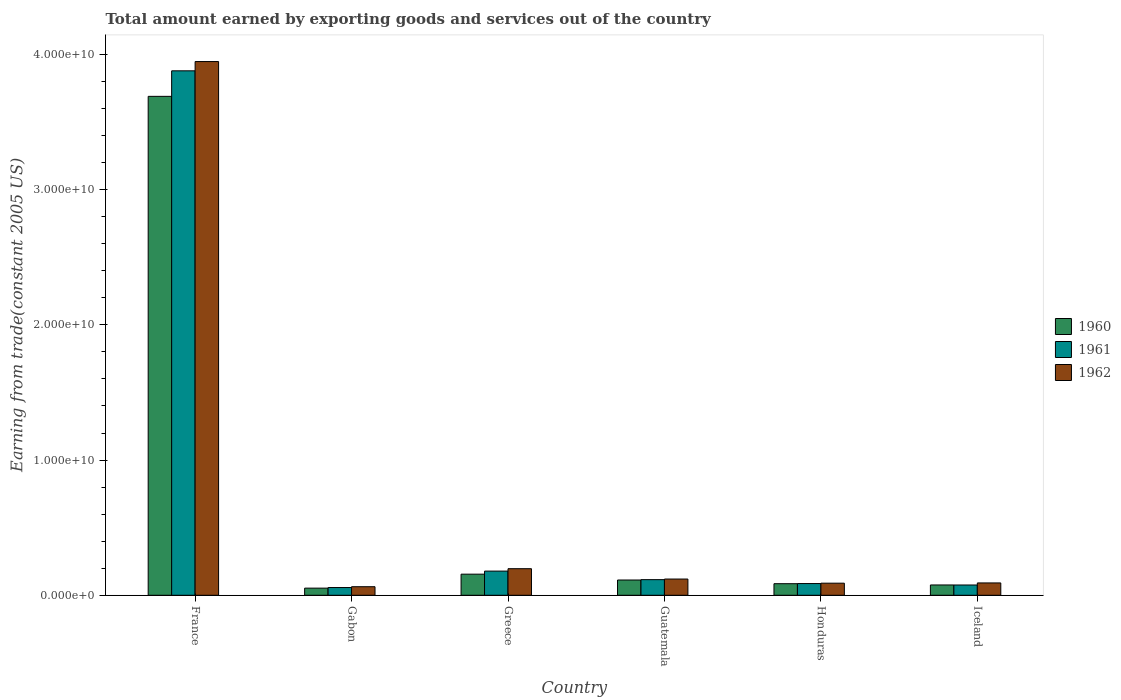How many different coloured bars are there?
Your answer should be very brief. 3. Are the number of bars per tick equal to the number of legend labels?
Ensure brevity in your answer.  Yes. How many bars are there on the 5th tick from the left?
Your answer should be very brief. 3. How many bars are there on the 5th tick from the right?
Offer a very short reply. 3. What is the label of the 3rd group of bars from the left?
Your response must be concise. Greece. In how many cases, is the number of bars for a given country not equal to the number of legend labels?
Make the answer very short. 0. What is the total amount earned by exporting goods and services in 1961 in Greece?
Keep it short and to the point. 1.79e+09. Across all countries, what is the maximum total amount earned by exporting goods and services in 1962?
Make the answer very short. 3.95e+1. Across all countries, what is the minimum total amount earned by exporting goods and services in 1961?
Offer a terse response. 5.72e+08. In which country was the total amount earned by exporting goods and services in 1960 minimum?
Your response must be concise. Gabon. What is the total total amount earned by exporting goods and services in 1960 in the graph?
Your response must be concise. 4.17e+1. What is the difference between the total amount earned by exporting goods and services in 1960 in Gabon and that in Greece?
Provide a succinct answer. -1.03e+09. What is the difference between the total amount earned by exporting goods and services in 1962 in Gabon and the total amount earned by exporting goods and services in 1960 in France?
Your answer should be compact. -3.63e+1. What is the average total amount earned by exporting goods and services in 1962 per country?
Ensure brevity in your answer.  7.51e+09. What is the difference between the total amount earned by exporting goods and services of/in 1961 and total amount earned by exporting goods and services of/in 1962 in Greece?
Offer a terse response. -1.78e+08. What is the ratio of the total amount earned by exporting goods and services in 1960 in Gabon to that in Honduras?
Ensure brevity in your answer.  0.62. Is the total amount earned by exporting goods and services in 1960 in France less than that in Honduras?
Make the answer very short. No. Is the difference between the total amount earned by exporting goods and services in 1961 in France and Gabon greater than the difference between the total amount earned by exporting goods and services in 1962 in France and Gabon?
Your answer should be compact. No. What is the difference between the highest and the second highest total amount earned by exporting goods and services in 1962?
Your answer should be very brief. 3.75e+1. What is the difference between the highest and the lowest total amount earned by exporting goods and services in 1961?
Offer a terse response. 3.82e+1. In how many countries, is the total amount earned by exporting goods and services in 1961 greater than the average total amount earned by exporting goods and services in 1961 taken over all countries?
Offer a terse response. 1. Is the sum of the total amount earned by exporting goods and services in 1961 in France and Greece greater than the maximum total amount earned by exporting goods and services in 1960 across all countries?
Give a very brief answer. Yes. What does the 3rd bar from the right in Honduras represents?
Keep it short and to the point. 1960. How many bars are there?
Make the answer very short. 18. Are all the bars in the graph horizontal?
Make the answer very short. No. How many countries are there in the graph?
Make the answer very short. 6. Are the values on the major ticks of Y-axis written in scientific E-notation?
Offer a very short reply. Yes. Does the graph contain any zero values?
Give a very brief answer. No. Does the graph contain grids?
Offer a very short reply. No. How are the legend labels stacked?
Give a very brief answer. Vertical. What is the title of the graph?
Your answer should be very brief. Total amount earned by exporting goods and services out of the country. Does "2007" appear as one of the legend labels in the graph?
Make the answer very short. No. What is the label or title of the Y-axis?
Provide a succinct answer. Earning from trade(constant 2005 US). What is the Earning from trade(constant 2005 US) of 1960 in France?
Keep it short and to the point. 3.69e+1. What is the Earning from trade(constant 2005 US) in 1961 in France?
Give a very brief answer. 3.88e+1. What is the Earning from trade(constant 2005 US) in 1962 in France?
Ensure brevity in your answer.  3.95e+1. What is the Earning from trade(constant 2005 US) in 1960 in Gabon?
Provide a succinct answer. 5.28e+08. What is the Earning from trade(constant 2005 US) in 1961 in Gabon?
Offer a terse response. 5.72e+08. What is the Earning from trade(constant 2005 US) of 1962 in Gabon?
Offer a terse response. 6.33e+08. What is the Earning from trade(constant 2005 US) of 1960 in Greece?
Offer a terse response. 1.56e+09. What is the Earning from trade(constant 2005 US) of 1961 in Greece?
Your answer should be compact. 1.79e+09. What is the Earning from trade(constant 2005 US) of 1962 in Greece?
Offer a terse response. 1.97e+09. What is the Earning from trade(constant 2005 US) in 1960 in Guatemala?
Offer a very short reply. 1.13e+09. What is the Earning from trade(constant 2005 US) of 1961 in Guatemala?
Your answer should be very brief. 1.16e+09. What is the Earning from trade(constant 2005 US) in 1962 in Guatemala?
Offer a terse response. 1.20e+09. What is the Earning from trade(constant 2005 US) in 1960 in Honduras?
Provide a succinct answer. 8.56e+08. What is the Earning from trade(constant 2005 US) in 1961 in Honduras?
Your answer should be very brief. 8.66e+08. What is the Earning from trade(constant 2005 US) in 1962 in Honduras?
Ensure brevity in your answer.  8.95e+08. What is the Earning from trade(constant 2005 US) of 1960 in Iceland?
Ensure brevity in your answer.  7.62e+08. What is the Earning from trade(constant 2005 US) of 1961 in Iceland?
Your answer should be compact. 7.60e+08. What is the Earning from trade(constant 2005 US) of 1962 in Iceland?
Offer a very short reply. 9.12e+08. Across all countries, what is the maximum Earning from trade(constant 2005 US) of 1960?
Your answer should be compact. 3.69e+1. Across all countries, what is the maximum Earning from trade(constant 2005 US) of 1961?
Offer a terse response. 3.88e+1. Across all countries, what is the maximum Earning from trade(constant 2005 US) in 1962?
Offer a very short reply. 3.95e+1. Across all countries, what is the minimum Earning from trade(constant 2005 US) in 1960?
Your answer should be very brief. 5.28e+08. Across all countries, what is the minimum Earning from trade(constant 2005 US) in 1961?
Ensure brevity in your answer.  5.72e+08. Across all countries, what is the minimum Earning from trade(constant 2005 US) in 1962?
Provide a succinct answer. 6.33e+08. What is the total Earning from trade(constant 2005 US) in 1960 in the graph?
Give a very brief answer. 4.17e+1. What is the total Earning from trade(constant 2005 US) of 1961 in the graph?
Your response must be concise. 4.39e+1. What is the total Earning from trade(constant 2005 US) in 1962 in the graph?
Provide a succinct answer. 4.51e+1. What is the difference between the Earning from trade(constant 2005 US) of 1960 in France and that in Gabon?
Your answer should be compact. 3.64e+1. What is the difference between the Earning from trade(constant 2005 US) in 1961 in France and that in Gabon?
Your response must be concise. 3.82e+1. What is the difference between the Earning from trade(constant 2005 US) in 1962 in France and that in Gabon?
Make the answer very short. 3.88e+1. What is the difference between the Earning from trade(constant 2005 US) of 1960 in France and that in Greece?
Your response must be concise. 3.53e+1. What is the difference between the Earning from trade(constant 2005 US) in 1961 in France and that in Greece?
Give a very brief answer. 3.70e+1. What is the difference between the Earning from trade(constant 2005 US) in 1962 in France and that in Greece?
Give a very brief answer. 3.75e+1. What is the difference between the Earning from trade(constant 2005 US) of 1960 in France and that in Guatemala?
Offer a terse response. 3.58e+1. What is the difference between the Earning from trade(constant 2005 US) of 1961 in France and that in Guatemala?
Your answer should be compact. 3.76e+1. What is the difference between the Earning from trade(constant 2005 US) in 1962 in France and that in Guatemala?
Provide a short and direct response. 3.83e+1. What is the difference between the Earning from trade(constant 2005 US) in 1960 in France and that in Honduras?
Your answer should be compact. 3.60e+1. What is the difference between the Earning from trade(constant 2005 US) in 1961 in France and that in Honduras?
Your answer should be very brief. 3.79e+1. What is the difference between the Earning from trade(constant 2005 US) of 1962 in France and that in Honduras?
Keep it short and to the point. 3.86e+1. What is the difference between the Earning from trade(constant 2005 US) of 1960 in France and that in Iceland?
Give a very brief answer. 3.61e+1. What is the difference between the Earning from trade(constant 2005 US) of 1961 in France and that in Iceland?
Keep it short and to the point. 3.80e+1. What is the difference between the Earning from trade(constant 2005 US) of 1962 in France and that in Iceland?
Ensure brevity in your answer.  3.86e+1. What is the difference between the Earning from trade(constant 2005 US) in 1960 in Gabon and that in Greece?
Offer a very short reply. -1.03e+09. What is the difference between the Earning from trade(constant 2005 US) of 1961 in Gabon and that in Greece?
Ensure brevity in your answer.  -1.22e+09. What is the difference between the Earning from trade(constant 2005 US) of 1962 in Gabon and that in Greece?
Provide a short and direct response. -1.33e+09. What is the difference between the Earning from trade(constant 2005 US) of 1960 in Gabon and that in Guatemala?
Make the answer very short. -6.01e+08. What is the difference between the Earning from trade(constant 2005 US) in 1961 in Gabon and that in Guatemala?
Give a very brief answer. -5.84e+08. What is the difference between the Earning from trade(constant 2005 US) in 1962 in Gabon and that in Guatemala?
Provide a succinct answer. -5.67e+08. What is the difference between the Earning from trade(constant 2005 US) of 1960 in Gabon and that in Honduras?
Ensure brevity in your answer.  -3.28e+08. What is the difference between the Earning from trade(constant 2005 US) of 1961 in Gabon and that in Honduras?
Provide a succinct answer. -2.94e+08. What is the difference between the Earning from trade(constant 2005 US) of 1962 in Gabon and that in Honduras?
Your answer should be compact. -2.61e+08. What is the difference between the Earning from trade(constant 2005 US) in 1960 in Gabon and that in Iceland?
Offer a very short reply. -2.34e+08. What is the difference between the Earning from trade(constant 2005 US) in 1961 in Gabon and that in Iceland?
Offer a terse response. -1.88e+08. What is the difference between the Earning from trade(constant 2005 US) of 1962 in Gabon and that in Iceland?
Offer a very short reply. -2.79e+08. What is the difference between the Earning from trade(constant 2005 US) in 1960 in Greece and that in Guatemala?
Your response must be concise. 4.31e+08. What is the difference between the Earning from trade(constant 2005 US) in 1961 in Greece and that in Guatemala?
Provide a succinct answer. 6.32e+08. What is the difference between the Earning from trade(constant 2005 US) in 1962 in Greece and that in Guatemala?
Ensure brevity in your answer.  7.65e+08. What is the difference between the Earning from trade(constant 2005 US) in 1960 in Greece and that in Honduras?
Your answer should be compact. 7.05e+08. What is the difference between the Earning from trade(constant 2005 US) of 1961 in Greece and that in Honduras?
Ensure brevity in your answer.  9.21e+08. What is the difference between the Earning from trade(constant 2005 US) of 1962 in Greece and that in Honduras?
Keep it short and to the point. 1.07e+09. What is the difference between the Earning from trade(constant 2005 US) in 1960 in Greece and that in Iceland?
Keep it short and to the point. 7.98e+08. What is the difference between the Earning from trade(constant 2005 US) in 1961 in Greece and that in Iceland?
Provide a succinct answer. 1.03e+09. What is the difference between the Earning from trade(constant 2005 US) in 1962 in Greece and that in Iceland?
Make the answer very short. 1.05e+09. What is the difference between the Earning from trade(constant 2005 US) in 1960 in Guatemala and that in Honduras?
Ensure brevity in your answer.  2.73e+08. What is the difference between the Earning from trade(constant 2005 US) in 1961 in Guatemala and that in Honduras?
Your answer should be compact. 2.89e+08. What is the difference between the Earning from trade(constant 2005 US) of 1962 in Guatemala and that in Honduras?
Give a very brief answer. 3.06e+08. What is the difference between the Earning from trade(constant 2005 US) of 1960 in Guatemala and that in Iceland?
Make the answer very short. 3.67e+08. What is the difference between the Earning from trade(constant 2005 US) in 1961 in Guatemala and that in Iceland?
Provide a succinct answer. 3.96e+08. What is the difference between the Earning from trade(constant 2005 US) in 1962 in Guatemala and that in Iceland?
Your answer should be very brief. 2.88e+08. What is the difference between the Earning from trade(constant 2005 US) in 1960 in Honduras and that in Iceland?
Give a very brief answer. 9.37e+07. What is the difference between the Earning from trade(constant 2005 US) of 1961 in Honduras and that in Iceland?
Your response must be concise. 1.06e+08. What is the difference between the Earning from trade(constant 2005 US) of 1962 in Honduras and that in Iceland?
Give a very brief answer. -1.79e+07. What is the difference between the Earning from trade(constant 2005 US) of 1960 in France and the Earning from trade(constant 2005 US) of 1961 in Gabon?
Your answer should be very brief. 3.63e+1. What is the difference between the Earning from trade(constant 2005 US) in 1960 in France and the Earning from trade(constant 2005 US) in 1962 in Gabon?
Provide a short and direct response. 3.63e+1. What is the difference between the Earning from trade(constant 2005 US) in 1961 in France and the Earning from trade(constant 2005 US) in 1962 in Gabon?
Make the answer very short. 3.82e+1. What is the difference between the Earning from trade(constant 2005 US) of 1960 in France and the Earning from trade(constant 2005 US) of 1961 in Greece?
Provide a short and direct response. 3.51e+1. What is the difference between the Earning from trade(constant 2005 US) of 1960 in France and the Earning from trade(constant 2005 US) of 1962 in Greece?
Keep it short and to the point. 3.49e+1. What is the difference between the Earning from trade(constant 2005 US) of 1961 in France and the Earning from trade(constant 2005 US) of 1962 in Greece?
Provide a short and direct response. 3.68e+1. What is the difference between the Earning from trade(constant 2005 US) in 1960 in France and the Earning from trade(constant 2005 US) in 1961 in Guatemala?
Your answer should be very brief. 3.57e+1. What is the difference between the Earning from trade(constant 2005 US) of 1960 in France and the Earning from trade(constant 2005 US) of 1962 in Guatemala?
Give a very brief answer. 3.57e+1. What is the difference between the Earning from trade(constant 2005 US) of 1961 in France and the Earning from trade(constant 2005 US) of 1962 in Guatemala?
Keep it short and to the point. 3.76e+1. What is the difference between the Earning from trade(constant 2005 US) in 1960 in France and the Earning from trade(constant 2005 US) in 1961 in Honduras?
Your response must be concise. 3.60e+1. What is the difference between the Earning from trade(constant 2005 US) in 1960 in France and the Earning from trade(constant 2005 US) in 1962 in Honduras?
Your answer should be compact. 3.60e+1. What is the difference between the Earning from trade(constant 2005 US) in 1961 in France and the Earning from trade(constant 2005 US) in 1962 in Honduras?
Your answer should be compact. 3.79e+1. What is the difference between the Earning from trade(constant 2005 US) in 1960 in France and the Earning from trade(constant 2005 US) in 1961 in Iceland?
Keep it short and to the point. 3.61e+1. What is the difference between the Earning from trade(constant 2005 US) in 1960 in France and the Earning from trade(constant 2005 US) in 1962 in Iceland?
Make the answer very short. 3.60e+1. What is the difference between the Earning from trade(constant 2005 US) in 1961 in France and the Earning from trade(constant 2005 US) in 1962 in Iceland?
Give a very brief answer. 3.79e+1. What is the difference between the Earning from trade(constant 2005 US) in 1960 in Gabon and the Earning from trade(constant 2005 US) in 1961 in Greece?
Your answer should be very brief. -1.26e+09. What is the difference between the Earning from trade(constant 2005 US) of 1960 in Gabon and the Earning from trade(constant 2005 US) of 1962 in Greece?
Give a very brief answer. -1.44e+09. What is the difference between the Earning from trade(constant 2005 US) of 1961 in Gabon and the Earning from trade(constant 2005 US) of 1962 in Greece?
Your response must be concise. -1.39e+09. What is the difference between the Earning from trade(constant 2005 US) in 1960 in Gabon and the Earning from trade(constant 2005 US) in 1961 in Guatemala?
Provide a succinct answer. -6.27e+08. What is the difference between the Earning from trade(constant 2005 US) of 1960 in Gabon and the Earning from trade(constant 2005 US) of 1962 in Guatemala?
Ensure brevity in your answer.  -6.72e+08. What is the difference between the Earning from trade(constant 2005 US) of 1961 in Gabon and the Earning from trade(constant 2005 US) of 1962 in Guatemala?
Your answer should be compact. -6.28e+08. What is the difference between the Earning from trade(constant 2005 US) of 1960 in Gabon and the Earning from trade(constant 2005 US) of 1961 in Honduras?
Offer a terse response. -3.38e+08. What is the difference between the Earning from trade(constant 2005 US) in 1960 in Gabon and the Earning from trade(constant 2005 US) in 1962 in Honduras?
Your response must be concise. -3.66e+08. What is the difference between the Earning from trade(constant 2005 US) of 1961 in Gabon and the Earning from trade(constant 2005 US) of 1962 in Honduras?
Provide a short and direct response. -3.23e+08. What is the difference between the Earning from trade(constant 2005 US) in 1960 in Gabon and the Earning from trade(constant 2005 US) in 1961 in Iceland?
Provide a short and direct response. -2.32e+08. What is the difference between the Earning from trade(constant 2005 US) of 1960 in Gabon and the Earning from trade(constant 2005 US) of 1962 in Iceland?
Keep it short and to the point. -3.84e+08. What is the difference between the Earning from trade(constant 2005 US) in 1961 in Gabon and the Earning from trade(constant 2005 US) in 1962 in Iceland?
Provide a succinct answer. -3.40e+08. What is the difference between the Earning from trade(constant 2005 US) of 1960 in Greece and the Earning from trade(constant 2005 US) of 1961 in Guatemala?
Provide a succinct answer. 4.05e+08. What is the difference between the Earning from trade(constant 2005 US) in 1960 in Greece and the Earning from trade(constant 2005 US) in 1962 in Guatemala?
Provide a short and direct response. 3.61e+08. What is the difference between the Earning from trade(constant 2005 US) of 1961 in Greece and the Earning from trade(constant 2005 US) of 1962 in Guatemala?
Give a very brief answer. 5.87e+08. What is the difference between the Earning from trade(constant 2005 US) of 1960 in Greece and the Earning from trade(constant 2005 US) of 1961 in Honduras?
Your answer should be very brief. 6.94e+08. What is the difference between the Earning from trade(constant 2005 US) in 1960 in Greece and the Earning from trade(constant 2005 US) in 1962 in Honduras?
Offer a terse response. 6.66e+08. What is the difference between the Earning from trade(constant 2005 US) in 1961 in Greece and the Earning from trade(constant 2005 US) in 1962 in Honduras?
Make the answer very short. 8.93e+08. What is the difference between the Earning from trade(constant 2005 US) in 1960 in Greece and the Earning from trade(constant 2005 US) in 1961 in Iceland?
Your answer should be compact. 8.01e+08. What is the difference between the Earning from trade(constant 2005 US) in 1960 in Greece and the Earning from trade(constant 2005 US) in 1962 in Iceland?
Your response must be concise. 6.48e+08. What is the difference between the Earning from trade(constant 2005 US) of 1961 in Greece and the Earning from trade(constant 2005 US) of 1962 in Iceland?
Provide a short and direct response. 8.75e+08. What is the difference between the Earning from trade(constant 2005 US) in 1960 in Guatemala and the Earning from trade(constant 2005 US) in 1961 in Honduras?
Make the answer very short. 2.63e+08. What is the difference between the Earning from trade(constant 2005 US) in 1960 in Guatemala and the Earning from trade(constant 2005 US) in 1962 in Honduras?
Make the answer very short. 2.35e+08. What is the difference between the Earning from trade(constant 2005 US) in 1961 in Guatemala and the Earning from trade(constant 2005 US) in 1962 in Honduras?
Your answer should be compact. 2.61e+08. What is the difference between the Earning from trade(constant 2005 US) of 1960 in Guatemala and the Earning from trade(constant 2005 US) of 1961 in Iceland?
Provide a succinct answer. 3.69e+08. What is the difference between the Earning from trade(constant 2005 US) in 1960 in Guatemala and the Earning from trade(constant 2005 US) in 1962 in Iceland?
Make the answer very short. 2.17e+08. What is the difference between the Earning from trade(constant 2005 US) in 1961 in Guatemala and the Earning from trade(constant 2005 US) in 1962 in Iceland?
Offer a very short reply. 2.43e+08. What is the difference between the Earning from trade(constant 2005 US) in 1960 in Honduras and the Earning from trade(constant 2005 US) in 1961 in Iceland?
Offer a very short reply. 9.63e+07. What is the difference between the Earning from trade(constant 2005 US) in 1960 in Honduras and the Earning from trade(constant 2005 US) in 1962 in Iceland?
Offer a terse response. -5.63e+07. What is the difference between the Earning from trade(constant 2005 US) of 1961 in Honduras and the Earning from trade(constant 2005 US) of 1962 in Iceland?
Offer a very short reply. -4.61e+07. What is the average Earning from trade(constant 2005 US) in 1960 per country?
Keep it short and to the point. 6.96e+09. What is the average Earning from trade(constant 2005 US) of 1961 per country?
Ensure brevity in your answer.  7.32e+09. What is the average Earning from trade(constant 2005 US) of 1962 per country?
Your response must be concise. 7.51e+09. What is the difference between the Earning from trade(constant 2005 US) in 1960 and Earning from trade(constant 2005 US) in 1961 in France?
Keep it short and to the point. -1.89e+09. What is the difference between the Earning from trade(constant 2005 US) of 1960 and Earning from trade(constant 2005 US) of 1962 in France?
Give a very brief answer. -2.57e+09. What is the difference between the Earning from trade(constant 2005 US) of 1961 and Earning from trade(constant 2005 US) of 1962 in France?
Your answer should be very brief. -6.85e+08. What is the difference between the Earning from trade(constant 2005 US) of 1960 and Earning from trade(constant 2005 US) of 1961 in Gabon?
Your answer should be very brief. -4.37e+07. What is the difference between the Earning from trade(constant 2005 US) of 1960 and Earning from trade(constant 2005 US) of 1962 in Gabon?
Offer a terse response. -1.05e+08. What is the difference between the Earning from trade(constant 2005 US) of 1961 and Earning from trade(constant 2005 US) of 1962 in Gabon?
Give a very brief answer. -6.11e+07. What is the difference between the Earning from trade(constant 2005 US) in 1960 and Earning from trade(constant 2005 US) in 1961 in Greece?
Your answer should be very brief. -2.27e+08. What is the difference between the Earning from trade(constant 2005 US) of 1960 and Earning from trade(constant 2005 US) of 1962 in Greece?
Make the answer very short. -4.05e+08. What is the difference between the Earning from trade(constant 2005 US) of 1961 and Earning from trade(constant 2005 US) of 1962 in Greece?
Provide a short and direct response. -1.78e+08. What is the difference between the Earning from trade(constant 2005 US) in 1960 and Earning from trade(constant 2005 US) in 1961 in Guatemala?
Ensure brevity in your answer.  -2.66e+07. What is the difference between the Earning from trade(constant 2005 US) in 1960 and Earning from trade(constant 2005 US) in 1962 in Guatemala?
Keep it short and to the point. -7.09e+07. What is the difference between the Earning from trade(constant 2005 US) of 1961 and Earning from trade(constant 2005 US) of 1962 in Guatemala?
Provide a succinct answer. -4.43e+07. What is the difference between the Earning from trade(constant 2005 US) of 1960 and Earning from trade(constant 2005 US) of 1961 in Honduras?
Your response must be concise. -1.02e+07. What is the difference between the Earning from trade(constant 2005 US) in 1960 and Earning from trade(constant 2005 US) in 1962 in Honduras?
Offer a very short reply. -3.84e+07. What is the difference between the Earning from trade(constant 2005 US) in 1961 and Earning from trade(constant 2005 US) in 1962 in Honduras?
Make the answer very short. -2.82e+07. What is the difference between the Earning from trade(constant 2005 US) of 1960 and Earning from trade(constant 2005 US) of 1961 in Iceland?
Your answer should be very brief. 2.61e+06. What is the difference between the Earning from trade(constant 2005 US) in 1960 and Earning from trade(constant 2005 US) in 1962 in Iceland?
Ensure brevity in your answer.  -1.50e+08. What is the difference between the Earning from trade(constant 2005 US) of 1961 and Earning from trade(constant 2005 US) of 1962 in Iceland?
Provide a short and direct response. -1.53e+08. What is the ratio of the Earning from trade(constant 2005 US) in 1960 in France to that in Gabon?
Give a very brief answer. 69.83. What is the ratio of the Earning from trade(constant 2005 US) in 1961 in France to that in Gabon?
Offer a very short reply. 67.8. What is the ratio of the Earning from trade(constant 2005 US) in 1962 in France to that in Gabon?
Ensure brevity in your answer.  62.34. What is the ratio of the Earning from trade(constant 2005 US) of 1960 in France to that in Greece?
Your answer should be compact. 23.64. What is the ratio of the Earning from trade(constant 2005 US) in 1961 in France to that in Greece?
Provide a succinct answer. 21.7. What is the ratio of the Earning from trade(constant 2005 US) in 1962 in France to that in Greece?
Your answer should be very brief. 20.08. What is the ratio of the Earning from trade(constant 2005 US) in 1960 in France to that in Guatemala?
Offer a very short reply. 32.67. What is the ratio of the Earning from trade(constant 2005 US) in 1961 in France to that in Guatemala?
Provide a short and direct response. 33.56. What is the ratio of the Earning from trade(constant 2005 US) of 1962 in France to that in Guatemala?
Give a very brief answer. 32.89. What is the ratio of the Earning from trade(constant 2005 US) in 1960 in France to that in Honduras?
Provide a short and direct response. 43.1. What is the ratio of the Earning from trade(constant 2005 US) of 1961 in France to that in Honduras?
Ensure brevity in your answer.  44.77. What is the ratio of the Earning from trade(constant 2005 US) in 1962 in France to that in Honduras?
Your answer should be very brief. 44.12. What is the ratio of the Earning from trade(constant 2005 US) of 1960 in France to that in Iceland?
Give a very brief answer. 48.39. What is the ratio of the Earning from trade(constant 2005 US) in 1961 in France to that in Iceland?
Your response must be concise. 51.04. What is the ratio of the Earning from trade(constant 2005 US) in 1962 in France to that in Iceland?
Provide a short and direct response. 43.26. What is the ratio of the Earning from trade(constant 2005 US) in 1960 in Gabon to that in Greece?
Your answer should be very brief. 0.34. What is the ratio of the Earning from trade(constant 2005 US) of 1961 in Gabon to that in Greece?
Offer a very short reply. 0.32. What is the ratio of the Earning from trade(constant 2005 US) of 1962 in Gabon to that in Greece?
Ensure brevity in your answer.  0.32. What is the ratio of the Earning from trade(constant 2005 US) in 1960 in Gabon to that in Guatemala?
Offer a very short reply. 0.47. What is the ratio of the Earning from trade(constant 2005 US) of 1961 in Gabon to that in Guatemala?
Offer a very short reply. 0.49. What is the ratio of the Earning from trade(constant 2005 US) of 1962 in Gabon to that in Guatemala?
Offer a very short reply. 0.53. What is the ratio of the Earning from trade(constant 2005 US) of 1960 in Gabon to that in Honduras?
Offer a very short reply. 0.62. What is the ratio of the Earning from trade(constant 2005 US) in 1961 in Gabon to that in Honduras?
Your response must be concise. 0.66. What is the ratio of the Earning from trade(constant 2005 US) of 1962 in Gabon to that in Honduras?
Offer a terse response. 0.71. What is the ratio of the Earning from trade(constant 2005 US) of 1960 in Gabon to that in Iceland?
Your response must be concise. 0.69. What is the ratio of the Earning from trade(constant 2005 US) in 1961 in Gabon to that in Iceland?
Offer a very short reply. 0.75. What is the ratio of the Earning from trade(constant 2005 US) in 1962 in Gabon to that in Iceland?
Your response must be concise. 0.69. What is the ratio of the Earning from trade(constant 2005 US) in 1960 in Greece to that in Guatemala?
Your response must be concise. 1.38. What is the ratio of the Earning from trade(constant 2005 US) of 1961 in Greece to that in Guatemala?
Give a very brief answer. 1.55. What is the ratio of the Earning from trade(constant 2005 US) in 1962 in Greece to that in Guatemala?
Keep it short and to the point. 1.64. What is the ratio of the Earning from trade(constant 2005 US) of 1960 in Greece to that in Honduras?
Your response must be concise. 1.82. What is the ratio of the Earning from trade(constant 2005 US) of 1961 in Greece to that in Honduras?
Your response must be concise. 2.06. What is the ratio of the Earning from trade(constant 2005 US) in 1962 in Greece to that in Honduras?
Offer a very short reply. 2.2. What is the ratio of the Earning from trade(constant 2005 US) of 1960 in Greece to that in Iceland?
Make the answer very short. 2.05. What is the ratio of the Earning from trade(constant 2005 US) of 1961 in Greece to that in Iceland?
Ensure brevity in your answer.  2.35. What is the ratio of the Earning from trade(constant 2005 US) in 1962 in Greece to that in Iceland?
Give a very brief answer. 2.15. What is the ratio of the Earning from trade(constant 2005 US) of 1960 in Guatemala to that in Honduras?
Give a very brief answer. 1.32. What is the ratio of the Earning from trade(constant 2005 US) in 1961 in Guatemala to that in Honduras?
Offer a very short reply. 1.33. What is the ratio of the Earning from trade(constant 2005 US) of 1962 in Guatemala to that in Honduras?
Your response must be concise. 1.34. What is the ratio of the Earning from trade(constant 2005 US) of 1960 in Guatemala to that in Iceland?
Ensure brevity in your answer.  1.48. What is the ratio of the Earning from trade(constant 2005 US) of 1961 in Guatemala to that in Iceland?
Give a very brief answer. 1.52. What is the ratio of the Earning from trade(constant 2005 US) in 1962 in Guatemala to that in Iceland?
Offer a terse response. 1.32. What is the ratio of the Earning from trade(constant 2005 US) of 1960 in Honduras to that in Iceland?
Your answer should be compact. 1.12. What is the ratio of the Earning from trade(constant 2005 US) in 1961 in Honduras to that in Iceland?
Offer a terse response. 1.14. What is the ratio of the Earning from trade(constant 2005 US) of 1962 in Honduras to that in Iceland?
Your response must be concise. 0.98. What is the difference between the highest and the second highest Earning from trade(constant 2005 US) in 1960?
Provide a short and direct response. 3.53e+1. What is the difference between the highest and the second highest Earning from trade(constant 2005 US) of 1961?
Your response must be concise. 3.70e+1. What is the difference between the highest and the second highest Earning from trade(constant 2005 US) in 1962?
Offer a terse response. 3.75e+1. What is the difference between the highest and the lowest Earning from trade(constant 2005 US) of 1960?
Provide a succinct answer. 3.64e+1. What is the difference between the highest and the lowest Earning from trade(constant 2005 US) of 1961?
Keep it short and to the point. 3.82e+1. What is the difference between the highest and the lowest Earning from trade(constant 2005 US) of 1962?
Provide a succinct answer. 3.88e+1. 